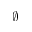<formula> <loc_0><loc_0><loc_500><loc_500>\emptyset</formula> 